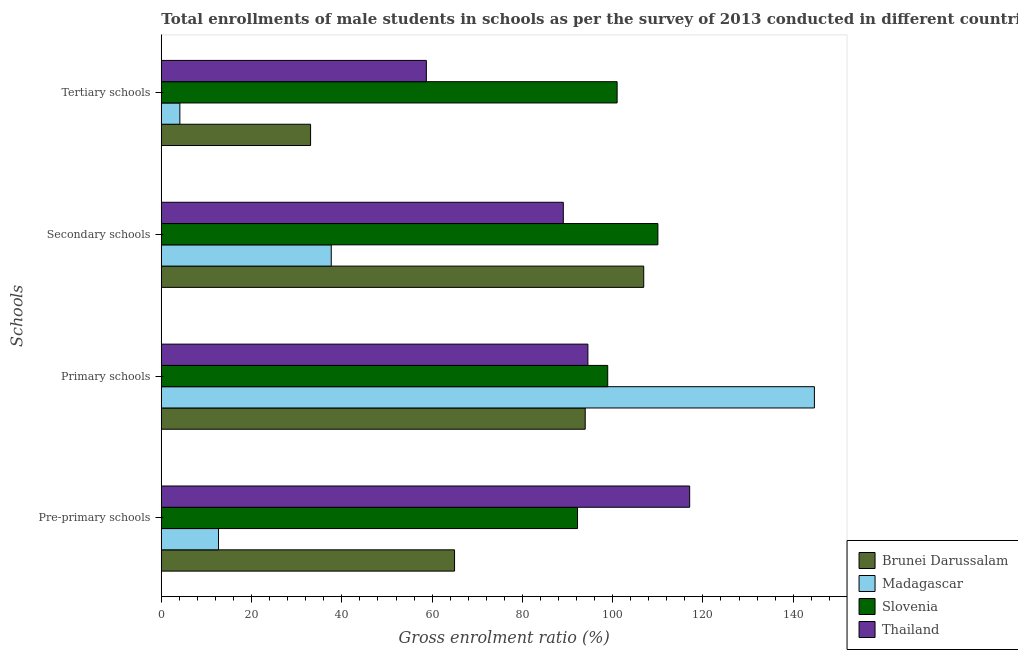How many different coloured bars are there?
Make the answer very short. 4. How many groups of bars are there?
Your answer should be compact. 4. Are the number of bars on each tick of the Y-axis equal?
Your answer should be compact. Yes. How many bars are there on the 3rd tick from the bottom?
Keep it short and to the point. 4. What is the label of the 2nd group of bars from the top?
Your answer should be compact. Secondary schools. What is the gross enrolment ratio(male) in tertiary schools in Madagascar?
Provide a succinct answer. 4.11. Across all countries, what is the maximum gross enrolment ratio(male) in secondary schools?
Give a very brief answer. 110.03. Across all countries, what is the minimum gross enrolment ratio(male) in tertiary schools?
Your answer should be compact. 4.11. In which country was the gross enrolment ratio(male) in primary schools maximum?
Keep it short and to the point. Madagascar. In which country was the gross enrolment ratio(male) in tertiary schools minimum?
Offer a very short reply. Madagascar. What is the total gross enrolment ratio(male) in primary schools in the graph?
Keep it short and to the point. 432.06. What is the difference between the gross enrolment ratio(male) in tertiary schools in Slovenia and that in Thailand?
Offer a very short reply. 42.27. What is the difference between the gross enrolment ratio(male) in secondary schools in Thailand and the gross enrolment ratio(male) in pre-primary schools in Brunei Darussalam?
Your response must be concise. 24.1. What is the average gross enrolment ratio(male) in primary schools per country?
Give a very brief answer. 108.01. What is the difference between the gross enrolment ratio(male) in secondary schools and gross enrolment ratio(male) in tertiary schools in Madagascar?
Your response must be concise. 33.54. In how many countries, is the gross enrolment ratio(male) in tertiary schools greater than 12 %?
Give a very brief answer. 3. What is the ratio of the gross enrolment ratio(male) in tertiary schools in Madagascar to that in Brunei Darussalam?
Keep it short and to the point. 0.12. Is the gross enrolment ratio(male) in primary schools in Thailand less than that in Brunei Darussalam?
Give a very brief answer. No. What is the difference between the highest and the second highest gross enrolment ratio(male) in tertiary schools?
Ensure brevity in your answer.  42.27. What is the difference between the highest and the lowest gross enrolment ratio(male) in pre-primary schools?
Offer a very short reply. 104.4. In how many countries, is the gross enrolment ratio(male) in pre-primary schools greater than the average gross enrolment ratio(male) in pre-primary schools taken over all countries?
Your response must be concise. 2. Is the sum of the gross enrolment ratio(male) in pre-primary schools in Madagascar and Thailand greater than the maximum gross enrolment ratio(male) in secondary schools across all countries?
Keep it short and to the point. Yes. What does the 2nd bar from the top in Secondary schools represents?
Provide a succinct answer. Slovenia. What does the 2nd bar from the bottom in Secondary schools represents?
Provide a succinct answer. Madagascar. Is it the case that in every country, the sum of the gross enrolment ratio(male) in pre-primary schools and gross enrolment ratio(male) in primary schools is greater than the gross enrolment ratio(male) in secondary schools?
Give a very brief answer. Yes. How many countries are there in the graph?
Ensure brevity in your answer.  4. Are the values on the major ticks of X-axis written in scientific E-notation?
Your answer should be compact. No. What is the title of the graph?
Keep it short and to the point. Total enrollments of male students in schools as per the survey of 2013 conducted in different countries. Does "Central Europe" appear as one of the legend labels in the graph?
Your response must be concise. No. What is the label or title of the Y-axis?
Your response must be concise. Schools. What is the Gross enrolment ratio (%) of Brunei Darussalam in Pre-primary schools?
Make the answer very short. 64.97. What is the Gross enrolment ratio (%) in Madagascar in Pre-primary schools?
Provide a succinct answer. 12.67. What is the Gross enrolment ratio (%) in Slovenia in Pre-primary schools?
Provide a succinct answer. 92.22. What is the Gross enrolment ratio (%) of Thailand in Pre-primary schools?
Your answer should be compact. 117.07. What is the Gross enrolment ratio (%) of Brunei Darussalam in Primary schools?
Make the answer very short. 93.93. What is the Gross enrolment ratio (%) of Madagascar in Primary schools?
Your response must be concise. 144.7. What is the Gross enrolment ratio (%) in Slovenia in Primary schools?
Make the answer very short. 98.91. What is the Gross enrolment ratio (%) of Thailand in Primary schools?
Your answer should be very brief. 94.52. What is the Gross enrolment ratio (%) of Brunei Darussalam in Secondary schools?
Keep it short and to the point. 106.89. What is the Gross enrolment ratio (%) of Madagascar in Secondary schools?
Your response must be concise. 37.65. What is the Gross enrolment ratio (%) in Slovenia in Secondary schools?
Ensure brevity in your answer.  110.03. What is the Gross enrolment ratio (%) of Thailand in Secondary schools?
Ensure brevity in your answer.  89.07. What is the Gross enrolment ratio (%) of Brunei Darussalam in Tertiary schools?
Give a very brief answer. 33.07. What is the Gross enrolment ratio (%) of Madagascar in Tertiary schools?
Your answer should be compact. 4.11. What is the Gross enrolment ratio (%) of Slovenia in Tertiary schools?
Provide a succinct answer. 101. What is the Gross enrolment ratio (%) in Thailand in Tertiary schools?
Make the answer very short. 58.72. Across all Schools, what is the maximum Gross enrolment ratio (%) in Brunei Darussalam?
Your answer should be compact. 106.89. Across all Schools, what is the maximum Gross enrolment ratio (%) of Madagascar?
Your answer should be very brief. 144.7. Across all Schools, what is the maximum Gross enrolment ratio (%) of Slovenia?
Make the answer very short. 110.03. Across all Schools, what is the maximum Gross enrolment ratio (%) in Thailand?
Your response must be concise. 117.07. Across all Schools, what is the minimum Gross enrolment ratio (%) of Brunei Darussalam?
Your response must be concise. 33.07. Across all Schools, what is the minimum Gross enrolment ratio (%) of Madagascar?
Provide a short and direct response. 4.11. Across all Schools, what is the minimum Gross enrolment ratio (%) in Slovenia?
Make the answer very short. 92.22. Across all Schools, what is the minimum Gross enrolment ratio (%) of Thailand?
Ensure brevity in your answer.  58.72. What is the total Gross enrolment ratio (%) in Brunei Darussalam in the graph?
Make the answer very short. 298.86. What is the total Gross enrolment ratio (%) of Madagascar in the graph?
Your response must be concise. 199.14. What is the total Gross enrolment ratio (%) in Slovenia in the graph?
Offer a terse response. 402.15. What is the total Gross enrolment ratio (%) in Thailand in the graph?
Keep it short and to the point. 359.38. What is the difference between the Gross enrolment ratio (%) in Brunei Darussalam in Pre-primary schools and that in Primary schools?
Provide a succinct answer. -28.95. What is the difference between the Gross enrolment ratio (%) in Madagascar in Pre-primary schools and that in Primary schools?
Provide a short and direct response. -132.03. What is the difference between the Gross enrolment ratio (%) of Slovenia in Pre-primary schools and that in Primary schools?
Provide a succinct answer. -6.69. What is the difference between the Gross enrolment ratio (%) of Thailand in Pre-primary schools and that in Primary schools?
Offer a very short reply. 22.55. What is the difference between the Gross enrolment ratio (%) in Brunei Darussalam in Pre-primary schools and that in Secondary schools?
Your response must be concise. -41.92. What is the difference between the Gross enrolment ratio (%) in Madagascar in Pre-primary schools and that in Secondary schools?
Offer a very short reply. -24.98. What is the difference between the Gross enrolment ratio (%) of Slovenia in Pre-primary schools and that in Secondary schools?
Give a very brief answer. -17.81. What is the difference between the Gross enrolment ratio (%) of Thailand in Pre-primary schools and that in Secondary schools?
Make the answer very short. 28. What is the difference between the Gross enrolment ratio (%) of Brunei Darussalam in Pre-primary schools and that in Tertiary schools?
Give a very brief answer. 31.9. What is the difference between the Gross enrolment ratio (%) in Madagascar in Pre-primary schools and that in Tertiary schools?
Give a very brief answer. 8.57. What is the difference between the Gross enrolment ratio (%) in Slovenia in Pre-primary schools and that in Tertiary schools?
Your response must be concise. -8.77. What is the difference between the Gross enrolment ratio (%) in Thailand in Pre-primary schools and that in Tertiary schools?
Provide a succinct answer. 58.35. What is the difference between the Gross enrolment ratio (%) in Brunei Darussalam in Primary schools and that in Secondary schools?
Offer a terse response. -12.97. What is the difference between the Gross enrolment ratio (%) of Madagascar in Primary schools and that in Secondary schools?
Provide a succinct answer. 107.05. What is the difference between the Gross enrolment ratio (%) in Slovenia in Primary schools and that in Secondary schools?
Ensure brevity in your answer.  -11.12. What is the difference between the Gross enrolment ratio (%) of Thailand in Primary schools and that in Secondary schools?
Make the answer very short. 5.45. What is the difference between the Gross enrolment ratio (%) of Brunei Darussalam in Primary schools and that in Tertiary schools?
Ensure brevity in your answer.  60.85. What is the difference between the Gross enrolment ratio (%) of Madagascar in Primary schools and that in Tertiary schools?
Your answer should be compact. 140.59. What is the difference between the Gross enrolment ratio (%) in Slovenia in Primary schools and that in Tertiary schools?
Provide a short and direct response. -2.08. What is the difference between the Gross enrolment ratio (%) of Thailand in Primary schools and that in Tertiary schools?
Give a very brief answer. 35.79. What is the difference between the Gross enrolment ratio (%) of Brunei Darussalam in Secondary schools and that in Tertiary schools?
Your response must be concise. 73.82. What is the difference between the Gross enrolment ratio (%) in Madagascar in Secondary schools and that in Tertiary schools?
Your answer should be compact. 33.54. What is the difference between the Gross enrolment ratio (%) in Slovenia in Secondary schools and that in Tertiary schools?
Your answer should be very brief. 9.03. What is the difference between the Gross enrolment ratio (%) in Thailand in Secondary schools and that in Tertiary schools?
Offer a very short reply. 30.35. What is the difference between the Gross enrolment ratio (%) of Brunei Darussalam in Pre-primary schools and the Gross enrolment ratio (%) of Madagascar in Primary schools?
Provide a succinct answer. -79.73. What is the difference between the Gross enrolment ratio (%) of Brunei Darussalam in Pre-primary schools and the Gross enrolment ratio (%) of Slovenia in Primary schools?
Your answer should be very brief. -33.94. What is the difference between the Gross enrolment ratio (%) in Brunei Darussalam in Pre-primary schools and the Gross enrolment ratio (%) in Thailand in Primary schools?
Your answer should be very brief. -29.55. What is the difference between the Gross enrolment ratio (%) of Madagascar in Pre-primary schools and the Gross enrolment ratio (%) of Slovenia in Primary schools?
Provide a short and direct response. -86.24. What is the difference between the Gross enrolment ratio (%) of Madagascar in Pre-primary schools and the Gross enrolment ratio (%) of Thailand in Primary schools?
Your answer should be compact. -81.84. What is the difference between the Gross enrolment ratio (%) of Slovenia in Pre-primary schools and the Gross enrolment ratio (%) of Thailand in Primary schools?
Your response must be concise. -2.3. What is the difference between the Gross enrolment ratio (%) of Brunei Darussalam in Pre-primary schools and the Gross enrolment ratio (%) of Madagascar in Secondary schools?
Make the answer very short. 27.32. What is the difference between the Gross enrolment ratio (%) in Brunei Darussalam in Pre-primary schools and the Gross enrolment ratio (%) in Slovenia in Secondary schools?
Your response must be concise. -45.06. What is the difference between the Gross enrolment ratio (%) of Brunei Darussalam in Pre-primary schools and the Gross enrolment ratio (%) of Thailand in Secondary schools?
Offer a terse response. -24.1. What is the difference between the Gross enrolment ratio (%) of Madagascar in Pre-primary schools and the Gross enrolment ratio (%) of Slovenia in Secondary schools?
Keep it short and to the point. -97.35. What is the difference between the Gross enrolment ratio (%) of Madagascar in Pre-primary schools and the Gross enrolment ratio (%) of Thailand in Secondary schools?
Ensure brevity in your answer.  -76.4. What is the difference between the Gross enrolment ratio (%) of Slovenia in Pre-primary schools and the Gross enrolment ratio (%) of Thailand in Secondary schools?
Give a very brief answer. 3.15. What is the difference between the Gross enrolment ratio (%) in Brunei Darussalam in Pre-primary schools and the Gross enrolment ratio (%) in Madagascar in Tertiary schools?
Make the answer very short. 60.86. What is the difference between the Gross enrolment ratio (%) in Brunei Darussalam in Pre-primary schools and the Gross enrolment ratio (%) in Slovenia in Tertiary schools?
Give a very brief answer. -36.02. What is the difference between the Gross enrolment ratio (%) of Brunei Darussalam in Pre-primary schools and the Gross enrolment ratio (%) of Thailand in Tertiary schools?
Give a very brief answer. 6.25. What is the difference between the Gross enrolment ratio (%) of Madagascar in Pre-primary schools and the Gross enrolment ratio (%) of Slovenia in Tertiary schools?
Offer a terse response. -88.32. What is the difference between the Gross enrolment ratio (%) in Madagascar in Pre-primary schools and the Gross enrolment ratio (%) in Thailand in Tertiary schools?
Your answer should be compact. -46.05. What is the difference between the Gross enrolment ratio (%) in Slovenia in Pre-primary schools and the Gross enrolment ratio (%) in Thailand in Tertiary schools?
Keep it short and to the point. 33.5. What is the difference between the Gross enrolment ratio (%) in Brunei Darussalam in Primary schools and the Gross enrolment ratio (%) in Madagascar in Secondary schools?
Your answer should be compact. 56.27. What is the difference between the Gross enrolment ratio (%) of Brunei Darussalam in Primary schools and the Gross enrolment ratio (%) of Slovenia in Secondary schools?
Give a very brief answer. -16.1. What is the difference between the Gross enrolment ratio (%) of Brunei Darussalam in Primary schools and the Gross enrolment ratio (%) of Thailand in Secondary schools?
Provide a short and direct response. 4.85. What is the difference between the Gross enrolment ratio (%) in Madagascar in Primary schools and the Gross enrolment ratio (%) in Slovenia in Secondary schools?
Keep it short and to the point. 34.67. What is the difference between the Gross enrolment ratio (%) of Madagascar in Primary schools and the Gross enrolment ratio (%) of Thailand in Secondary schools?
Offer a terse response. 55.63. What is the difference between the Gross enrolment ratio (%) of Slovenia in Primary schools and the Gross enrolment ratio (%) of Thailand in Secondary schools?
Your response must be concise. 9.84. What is the difference between the Gross enrolment ratio (%) of Brunei Darussalam in Primary schools and the Gross enrolment ratio (%) of Madagascar in Tertiary schools?
Ensure brevity in your answer.  89.82. What is the difference between the Gross enrolment ratio (%) in Brunei Darussalam in Primary schools and the Gross enrolment ratio (%) in Slovenia in Tertiary schools?
Ensure brevity in your answer.  -7.07. What is the difference between the Gross enrolment ratio (%) in Brunei Darussalam in Primary schools and the Gross enrolment ratio (%) in Thailand in Tertiary schools?
Offer a terse response. 35.2. What is the difference between the Gross enrolment ratio (%) in Madagascar in Primary schools and the Gross enrolment ratio (%) in Slovenia in Tertiary schools?
Offer a very short reply. 43.71. What is the difference between the Gross enrolment ratio (%) in Madagascar in Primary schools and the Gross enrolment ratio (%) in Thailand in Tertiary schools?
Give a very brief answer. 85.98. What is the difference between the Gross enrolment ratio (%) in Slovenia in Primary schools and the Gross enrolment ratio (%) in Thailand in Tertiary schools?
Give a very brief answer. 40.19. What is the difference between the Gross enrolment ratio (%) of Brunei Darussalam in Secondary schools and the Gross enrolment ratio (%) of Madagascar in Tertiary schools?
Provide a succinct answer. 102.78. What is the difference between the Gross enrolment ratio (%) in Brunei Darussalam in Secondary schools and the Gross enrolment ratio (%) in Slovenia in Tertiary schools?
Offer a very short reply. 5.9. What is the difference between the Gross enrolment ratio (%) of Brunei Darussalam in Secondary schools and the Gross enrolment ratio (%) of Thailand in Tertiary schools?
Provide a short and direct response. 48.17. What is the difference between the Gross enrolment ratio (%) of Madagascar in Secondary schools and the Gross enrolment ratio (%) of Slovenia in Tertiary schools?
Provide a short and direct response. -63.34. What is the difference between the Gross enrolment ratio (%) of Madagascar in Secondary schools and the Gross enrolment ratio (%) of Thailand in Tertiary schools?
Your response must be concise. -21.07. What is the difference between the Gross enrolment ratio (%) of Slovenia in Secondary schools and the Gross enrolment ratio (%) of Thailand in Tertiary schools?
Give a very brief answer. 51.3. What is the average Gross enrolment ratio (%) in Brunei Darussalam per Schools?
Your answer should be very brief. 74.72. What is the average Gross enrolment ratio (%) of Madagascar per Schools?
Provide a succinct answer. 49.78. What is the average Gross enrolment ratio (%) in Slovenia per Schools?
Make the answer very short. 100.54. What is the average Gross enrolment ratio (%) of Thailand per Schools?
Make the answer very short. 89.85. What is the difference between the Gross enrolment ratio (%) in Brunei Darussalam and Gross enrolment ratio (%) in Madagascar in Pre-primary schools?
Keep it short and to the point. 52.3. What is the difference between the Gross enrolment ratio (%) of Brunei Darussalam and Gross enrolment ratio (%) of Slovenia in Pre-primary schools?
Offer a very short reply. -27.25. What is the difference between the Gross enrolment ratio (%) of Brunei Darussalam and Gross enrolment ratio (%) of Thailand in Pre-primary schools?
Keep it short and to the point. -52.1. What is the difference between the Gross enrolment ratio (%) of Madagascar and Gross enrolment ratio (%) of Slovenia in Pre-primary schools?
Your answer should be compact. -79.55. What is the difference between the Gross enrolment ratio (%) of Madagascar and Gross enrolment ratio (%) of Thailand in Pre-primary schools?
Give a very brief answer. -104.4. What is the difference between the Gross enrolment ratio (%) of Slovenia and Gross enrolment ratio (%) of Thailand in Pre-primary schools?
Your answer should be compact. -24.85. What is the difference between the Gross enrolment ratio (%) in Brunei Darussalam and Gross enrolment ratio (%) in Madagascar in Primary schools?
Your response must be concise. -50.78. What is the difference between the Gross enrolment ratio (%) in Brunei Darussalam and Gross enrolment ratio (%) in Slovenia in Primary schools?
Ensure brevity in your answer.  -4.99. What is the difference between the Gross enrolment ratio (%) of Brunei Darussalam and Gross enrolment ratio (%) of Thailand in Primary schools?
Your answer should be very brief. -0.59. What is the difference between the Gross enrolment ratio (%) in Madagascar and Gross enrolment ratio (%) in Slovenia in Primary schools?
Provide a succinct answer. 45.79. What is the difference between the Gross enrolment ratio (%) in Madagascar and Gross enrolment ratio (%) in Thailand in Primary schools?
Provide a succinct answer. 50.18. What is the difference between the Gross enrolment ratio (%) of Slovenia and Gross enrolment ratio (%) of Thailand in Primary schools?
Your response must be concise. 4.39. What is the difference between the Gross enrolment ratio (%) of Brunei Darussalam and Gross enrolment ratio (%) of Madagascar in Secondary schools?
Your answer should be compact. 69.24. What is the difference between the Gross enrolment ratio (%) of Brunei Darussalam and Gross enrolment ratio (%) of Slovenia in Secondary schools?
Keep it short and to the point. -3.14. What is the difference between the Gross enrolment ratio (%) of Brunei Darussalam and Gross enrolment ratio (%) of Thailand in Secondary schools?
Your answer should be compact. 17.82. What is the difference between the Gross enrolment ratio (%) in Madagascar and Gross enrolment ratio (%) in Slovenia in Secondary schools?
Make the answer very short. -72.38. What is the difference between the Gross enrolment ratio (%) of Madagascar and Gross enrolment ratio (%) of Thailand in Secondary schools?
Ensure brevity in your answer.  -51.42. What is the difference between the Gross enrolment ratio (%) of Slovenia and Gross enrolment ratio (%) of Thailand in Secondary schools?
Offer a very short reply. 20.96. What is the difference between the Gross enrolment ratio (%) of Brunei Darussalam and Gross enrolment ratio (%) of Madagascar in Tertiary schools?
Keep it short and to the point. 28.96. What is the difference between the Gross enrolment ratio (%) in Brunei Darussalam and Gross enrolment ratio (%) in Slovenia in Tertiary schools?
Give a very brief answer. -67.92. What is the difference between the Gross enrolment ratio (%) of Brunei Darussalam and Gross enrolment ratio (%) of Thailand in Tertiary schools?
Offer a terse response. -25.65. What is the difference between the Gross enrolment ratio (%) of Madagascar and Gross enrolment ratio (%) of Slovenia in Tertiary schools?
Your answer should be very brief. -96.89. What is the difference between the Gross enrolment ratio (%) of Madagascar and Gross enrolment ratio (%) of Thailand in Tertiary schools?
Ensure brevity in your answer.  -54.62. What is the difference between the Gross enrolment ratio (%) of Slovenia and Gross enrolment ratio (%) of Thailand in Tertiary schools?
Your answer should be compact. 42.27. What is the ratio of the Gross enrolment ratio (%) of Brunei Darussalam in Pre-primary schools to that in Primary schools?
Offer a very short reply. 0.69. What is the ratio of the Gross enrolment ratio (%) of Madagascar in Pre-primary schools to that in Primary schools?
Give a very brief answer. 0.09. What is the ratio of the Gross enrolment ratio (%) of Slovenia in Pre-primary schools to that in Primary schools?
Provide a succinct answer. 0.93. What is the ratio of the Gross enrolment ratio (%) of Thailand in Pre-primary schools to that in Primary schools?
Offer a terse response. 1.24. What is the ratio of the Gross enrolment ratio (%) in Brunei Darussalam in Pre-primary schools to that in Secondary schools?
Provide a short and direct response. 0.61. What is the ratio of the Gross enrolment ratio (%) of Madagascar in Pre-primary schools to that in Secondary schools?
Your response must be concise. 0.34. What is the ratio of the Gross enrolment ratio (%) of Slovenia in Pre-primary schools to that in Secondary schools?
Ensure brevity in your answer.  0.84. What is the ratio of the Gross enrolment ratio (%) of Thailand in Pre-primary schools to that in Secondary schools?
Your answer should be compact. 1.31. What is the ratio of the Gross enrolment ratio (%) in Brunei Darussalam in Pre-primary schools to that in Tertiary schools?
Your response must be concise. 1.96. What is the ratio of the Gross enrolment ratio (%) in Madagascar in Pre-primary schools to that in Tertiary schools?
Your answer should be compact. 3.08. What is the ratio of the Gross enrolment ratio (%) of Slovenia in Pre-primary schools to that in Tertiary schools?
Keep it short and to the point. 0.91. What is the ratio of the Gross enrolment ratio (%) of Thailand in Pre-primary schools to that in Tertiary schools?
Your response must be concise. 1.99. What is the ratio of the Gross enrolment ratio (%) in Brunei Darussalam in Primary schools to that in Secondary schools?
Provide a succinct answer. 0.88. What is the ratio of the Gross enrolment ratio (%) of Madagascar in Primary schools to that in Secondary schools?
Offer a very short reply. 3.84. What is the ratio of the Gross enrolment ratio (%) in Slovenia in Primary schools to that in Secondary schools?
Offer a very short reply. 0.9. What is the ratio of the Gross enrolment ratio (%) in Thailand in Primary schools to that in Secondary schools?
Offer a very short reply. 1.06. What is the ratio of the Gross enrolment ratio (%) of Brunei Darussalam in Primary schools to that in Tertiary schools?
Ensure brevity in your answer.  2.84. What is the ratio of the Gross enrolment ratio (%) of Madagascar in Primary schools to that in Tertiary schools?
Keep it short and to the point. 35.22. What is the ratio of the Gross enrolment ratio (%) in Slovenia in Primary schools to that in Tertiary schools?
Your response must be concise. 0.98. What is the ratio of the Gross enrolment ratio (%) in Thailand in Primary schools to that in Tertiary schools?
Offer a terse response. 1.61. What is the ratio of the Gross enrolment ratio (%) of Brunei Darussalam in Secondary schools to that in Tertiary schools?
Keep it short and to the point. 3.23. What is the ratio of the Gross enrolment ratio (%) of Madagascar in Secondary schools to that in Tertiary schools?
Your answer should be compact. 9.16. What is the ratio of the Gross enrolment ratio (%) in Slovenia in Secondary schools to that in Tertiary schools?
Give a very brief answer. 1.09. What is the ratio of the Gross enrolment ratio (%) of Thailand in Secondary schools to that in Tertiary schools?
Your answer should be very brief. 1.52. What is the difference between the highest and the second highest Gross enrolment ratio (%) of Brunei Darussalam?
Keep it short and to the point. 12.97. What is the difference between the highest and the second highest Gross enrolment ratio (%) of Madagascar?
Ensure brevity in your answer.  107.05. What is the difference between the highest and the second highest Gross enrolment ratio (%) in Slovenia?
Ensure brevity in your answer.  9.03. What is the difference between the highest and the second highest Gross enrolment ratio (%) of Thailand?
Ensure brevity in your answer.  22.55. What is the difference between the highest and the lowest Gross enrolment ratio (%) of Brunei Darussalam?
Give a very brief answer. 73.82. What is the difference between the highest and the lowest Gross enrolment ratio (%) in Madagascar?
Ensure brevity in your answer.  140.59. What is the difference between the highest and the lowest Gross enrolment ratio (%) in Slovenia?
Offer a very short reply. 17.81. What is the difference between the highest and the lowest Gross enrolment ratio (%) of Thailand?
Your response must be concise. 58.35. 